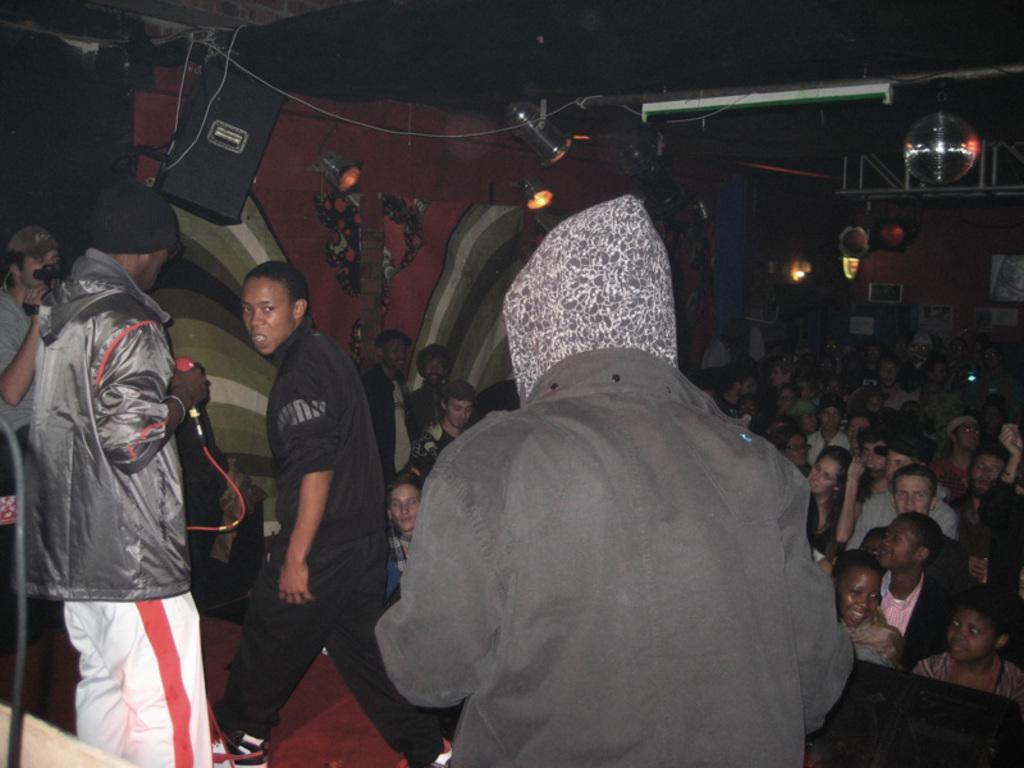Who or what can be seen in the image? There are people in the image. What can be observed in the background or surrounding the people? There are lights in the image. What object is present that might be used for amplifying sound? There is a microphone in the image. What direction is the actor facing in the image? There is no actor present in the image, and therefore no direction can be determined. 